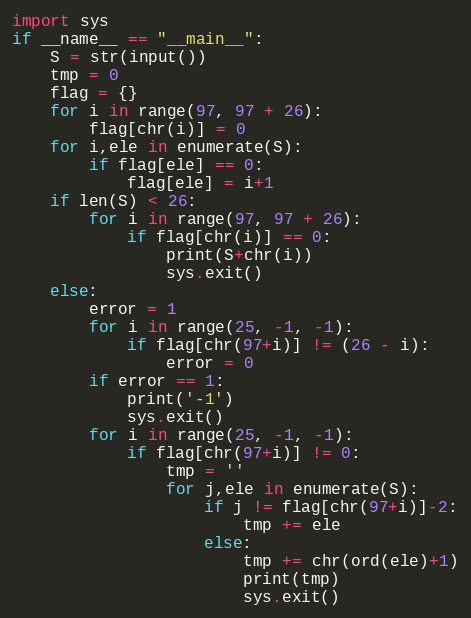Convert code to text. <code><loc_0><loc_0><loc_500><loc_500><_Python_>import sys
if __name__ == "__main__":
    S = str(input())
    tmp = 0
    flag = {}
    for i in range(97, 97 + 26):
        flag[chr(i)] = 0
    for i,ele in enumerate(S):
        if flag[ele] == 0:
            flag[ele] = i+1
    if len(S) < 26:
        for i in range(97, 97 + 26):
            if flag[chr(i)] == 0:
                print(S+chr(i))
                sys.exit()
    else:
        error = 1
        for i in range(25, -1, -1):
            if flag[chr(97+i)] != (26 - i):
                error = 0
        if error == 1:
            print('-1')
            sys.exit()
        for i in range(25, -1, -1):
            if flag[chr(97+i)] != 0:
                tmp = ''
                for j,ele in enumerate(S):
                    if j != flag[chr(97+i)]-2:
                        tmp += ele
                    else:
                        tmp += chr(ord(ele)+1)
                        print(tmp)
                        sys.exit()</code> 